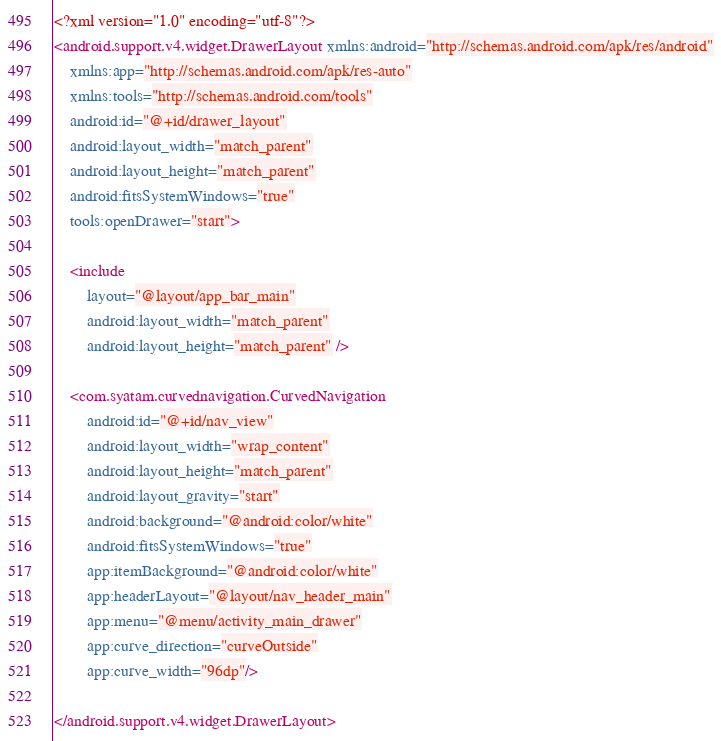Convert code to text. <code><loc_0><loc_0><loc_500><loc_500><_XML_><?xml version="1.0" encoding="utf-8"?>
<android.support.v4.widget.DrawerLayout xmlns:android="http://schemas.android.com/apk/res/android"
    xmlns:app="http://schemas.android.com/apk/res-auto"
    xmlns:tools="http://schemas.android.com/tools"
    android:id="@+id/drawer_layout"
    android:layout_width="match_parent"
    android:layout_height="match_parent"
    android:fitsSystemWindows="true"
    tools:openDrawer="start">

    <include
        layout="@layout/app_bar_main"
        android:layout_width="match_parent"
        android:layout_height="match_parent" />

    <com.syatam.curvednavigation.CurvedNavigation
        android:id="@+id/nav_view"
        android:layout_width="wrap_content"
        android:layout_height="match_parent"
        android:layout_gravity="start"
        android:background="@android:color/white"
        android:fitsSystemWindows="true"
        app:itemBackground="@android:color/white"
        app:headerLayout="@layout/nav_header_main"
        app:menu="@menu/activity_main_drawer"
        app:curve_direction="curveOutside"
        app:curve_width="96dp"/>

</android.support.v4.widget.DrawerLayout>
</code> 